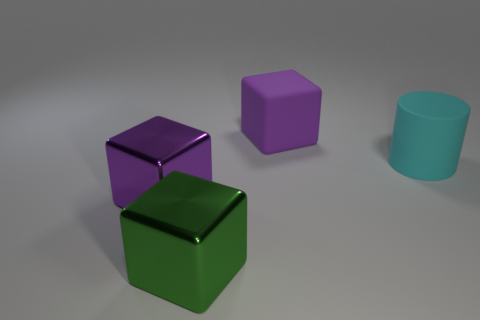What is the size of the metal thing that is the same color as the large matte cube?
Your answer should be very brief. Large. Are there any purple things that have the same material as the green cube?
Your answer should be very brief. Yes. What is the color of the big rubber cube?
Your answer should be compact. Purple. There is a object left of the green shiny cube; does it have the same shape as the big green metal thing?
Give a very brief answer. Yes. There is a large rubber thing that is on the right side of the large purple block right of the green metal object right of the big purple metal object; what is its shape?
Provide a short and direct response. Cylinder. What material is the block to the left of the big green shiny thing?
Give a very brief answer. Metal. There is a matte cylinder that is the same size as the purple rubber block; what is its color?
Keep it short and to the point. Cyan. How many other objects are the same shape as the green thing?
Offer a terse response. 2. Is the cyan rubber cylinder the same size as the green metal cube?
Provide a succinct answer. Yes. Are there more large green objects behind the big purple shiny object than purple matte objects in front of the large cyan thing?
Provide a succinct answer. No. 